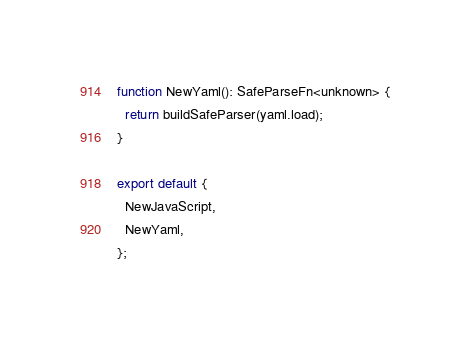<code> <loc_0><loc_0><loc_500><loc_500><_TypeScript_>function NewYaml(): SafeParseFn<unknown> {
  return buildSafeParser(yaml.load);
}

export default {
  NewJavaScript,
  NewYaml,
};
</code> 